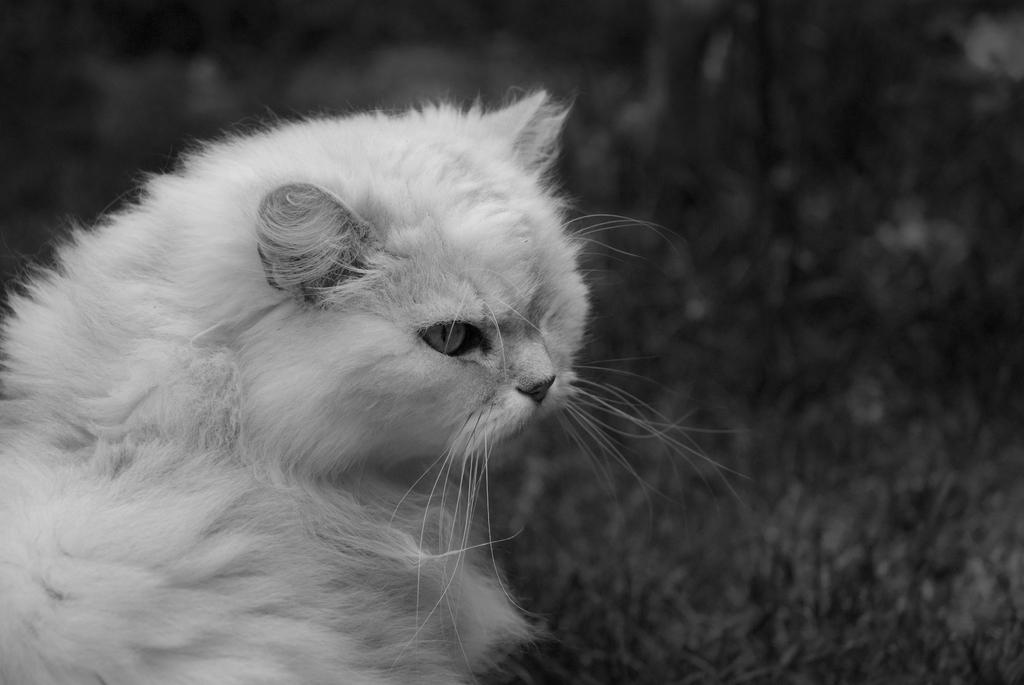What type of animal is in the image? There is a white cat in the image. What is the cat doing in the image? The cat is looking at something. What color is the background of the image? The background of the image is grey. Is the image in color or black and white? The image might be black and white. Can you tell me how many sacks the cat is carrying in the image? There are no sacks present in the image, so it is not possible to determine how many the cat might be carrying. 